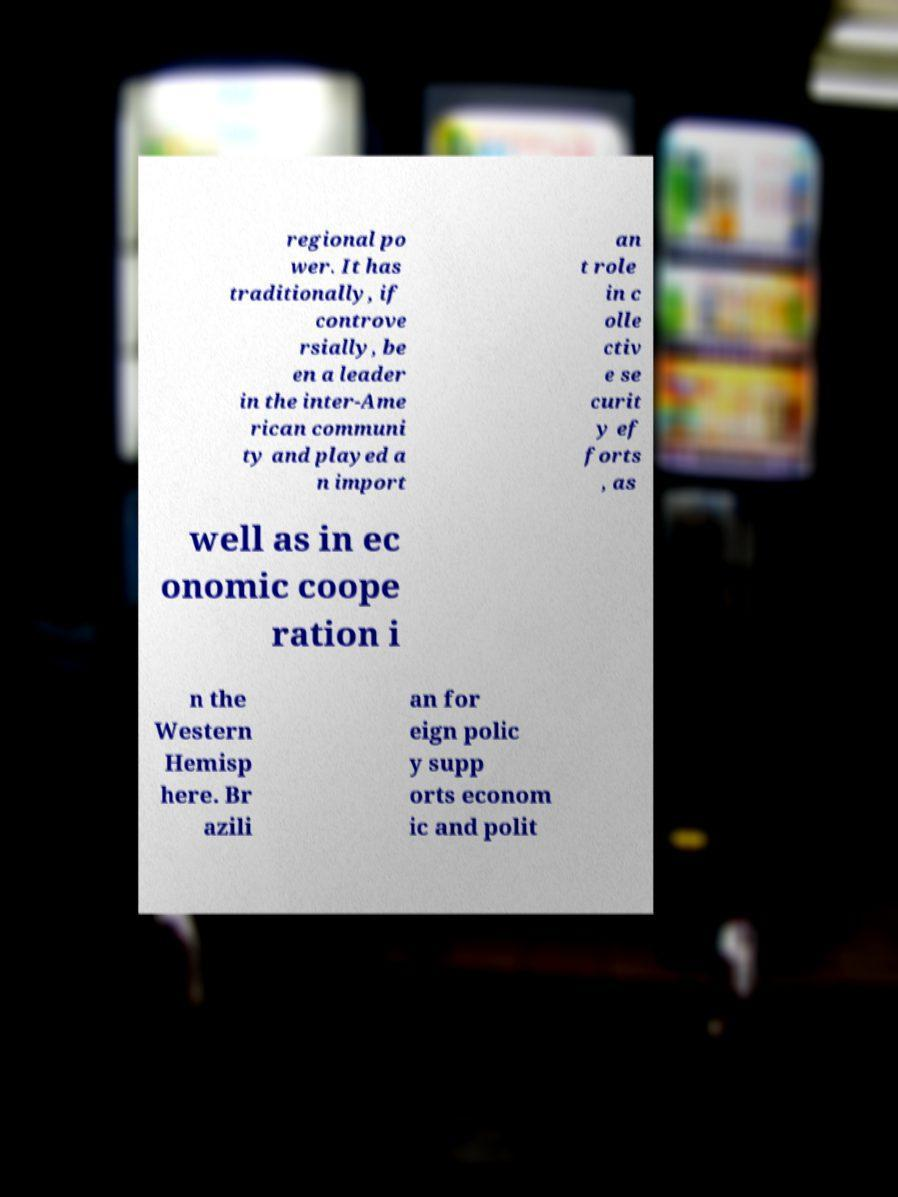Please identify and transcribe the text found in this image. regional po wer. It has traditionally, if controve rsially, be en a leader in the inter-Ame rican communi ty and played a n import an t role in c olle ctiv e se curit y ef forts , as well as in ec onomic coope ration i n the Western Hemisp here. Br azili an for eign polic y supp orts econom ic and polit 